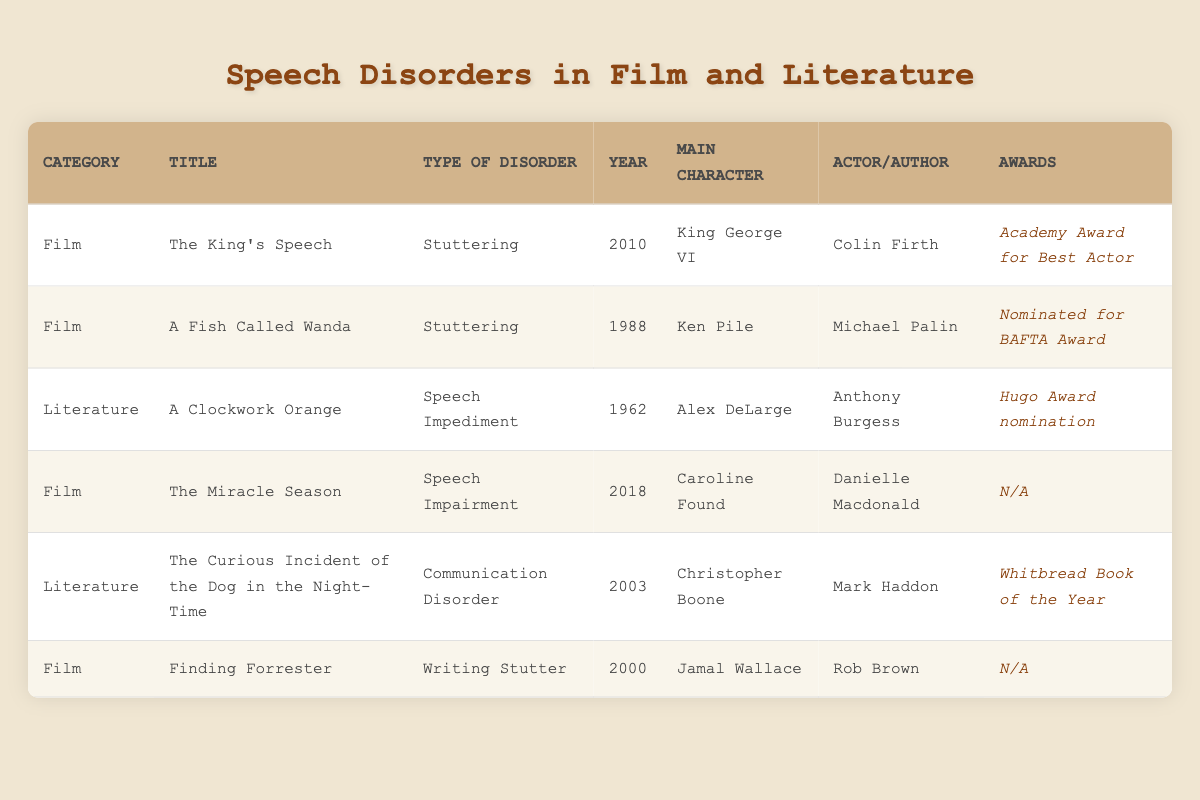What types of speech disorders are represented in film? The table lists three types of speech disorders in films: Stuttering, Speech Impairment, and Writing Stutter. These can be found in the rows corresponding to the film category.
Answer: Stuttering, Speech Impairment, Writing Stutter How many films feature stuttering as a speech disorder? By scanning the "Type of Disorder" column and counting entries for stuttering, we find two films: "The King's Speech" and "A Fish Called Wanda."
Answer: 2 Is "The Curious Incident of the Dog in the Night-Time" authored by Anthony Burgess? Looking at the "Author" column for that title, we find that the author is actually Mark Haddon, not Anthony Burgess, making the statement false.
Answer: No Which film has won an Academy Award, and who starred in it? The film "The King's Speech" won an Academy Award for Best Actor, with Colin Firth as the actor. This can be found in the relevant rows of the "Awards" and "Actor" columns.
Answer: The King's Speech, Colin Firth What is the average year of release for films listed in the table? To calculate the average, sum the release years of the films (2010 + 1988 + 2018 + 2000) and divide by the number of films (4). The average year is (2010 + 1988 + 2018 + 2000) / 4 = 2004.
Answer: 2004 Do any works in this table lack awards? By checking the "Awards" column, we see that "The Miracle Season" and "Finding Forrester" both have "N/A" listed, indicating no awards, making the statement true.
Answer: Yes Which type of disorder is portrayed by the character Caroline Found and in which year was the film released? From the table, Caroline Found, appearing in "The Miracle Season," has a speech impairment, and the film was released in 2018, as indicated in the corresponding columns.
Answer: Speech Impairment, 2018 Which actor has been nominated for a BAFTA Award according to this table? The table states that Michael Palin is the actor from "A Fish Called Wanda," who was nominated for a BAFTA Award, found under the respective row.
Answer: Michael Palin 